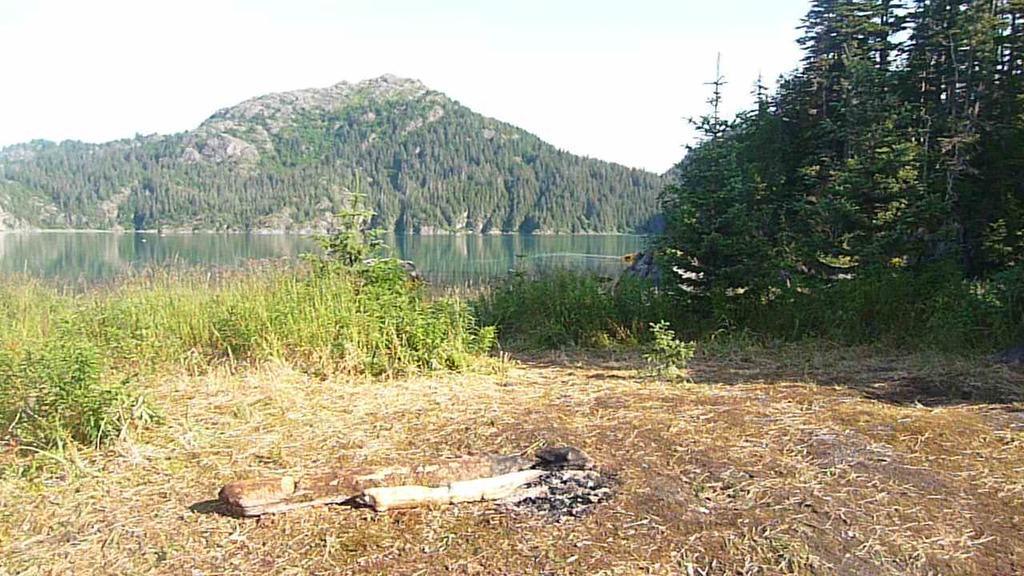Please provide a concise description of this image. In the image we can see grass, water, trees, hills and the sky. Here we can see half burned wooden log. 